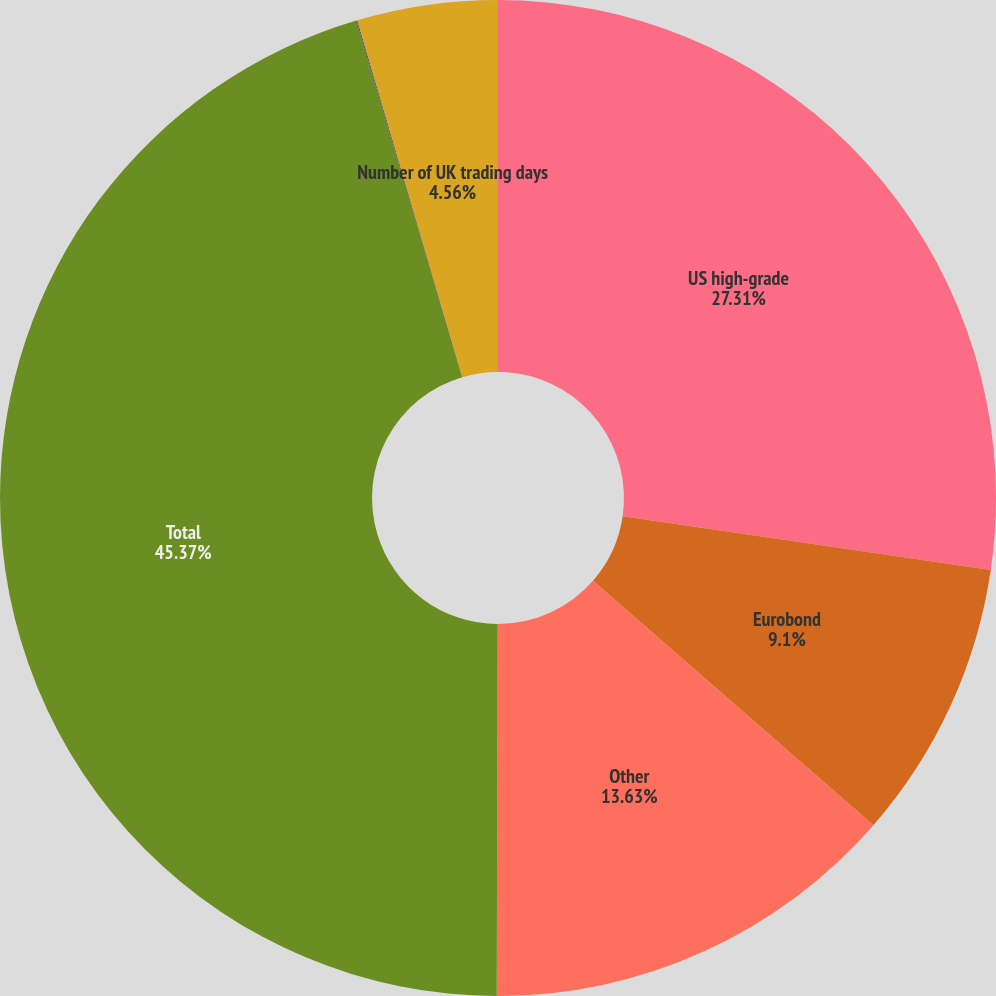Convert chart. <chart><loc_0><loc_0><loc_500><loc_500><pie_chart><fcel>US high-grade<fcel>Eurobond<fcel>Other<fcel>Total<fcel>Number of US trading days<fcel>Number of UK trading days<nl><fcel>27.31%<fcel>9.1%<fcel>13.63%<fcel>45.37%<fcel>0.03%<fcel>4.56%<nl></chart> 